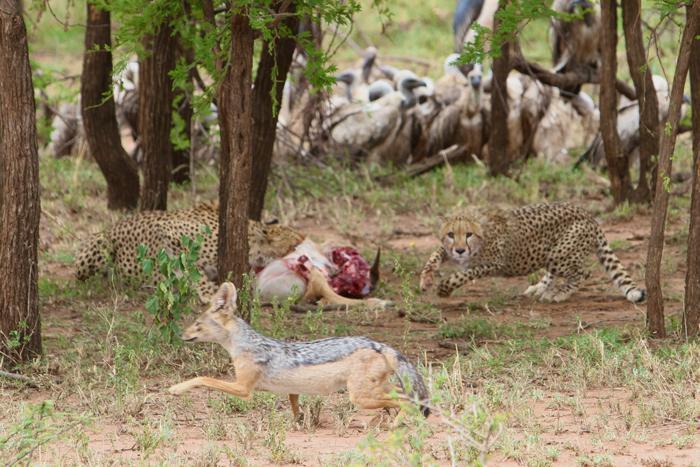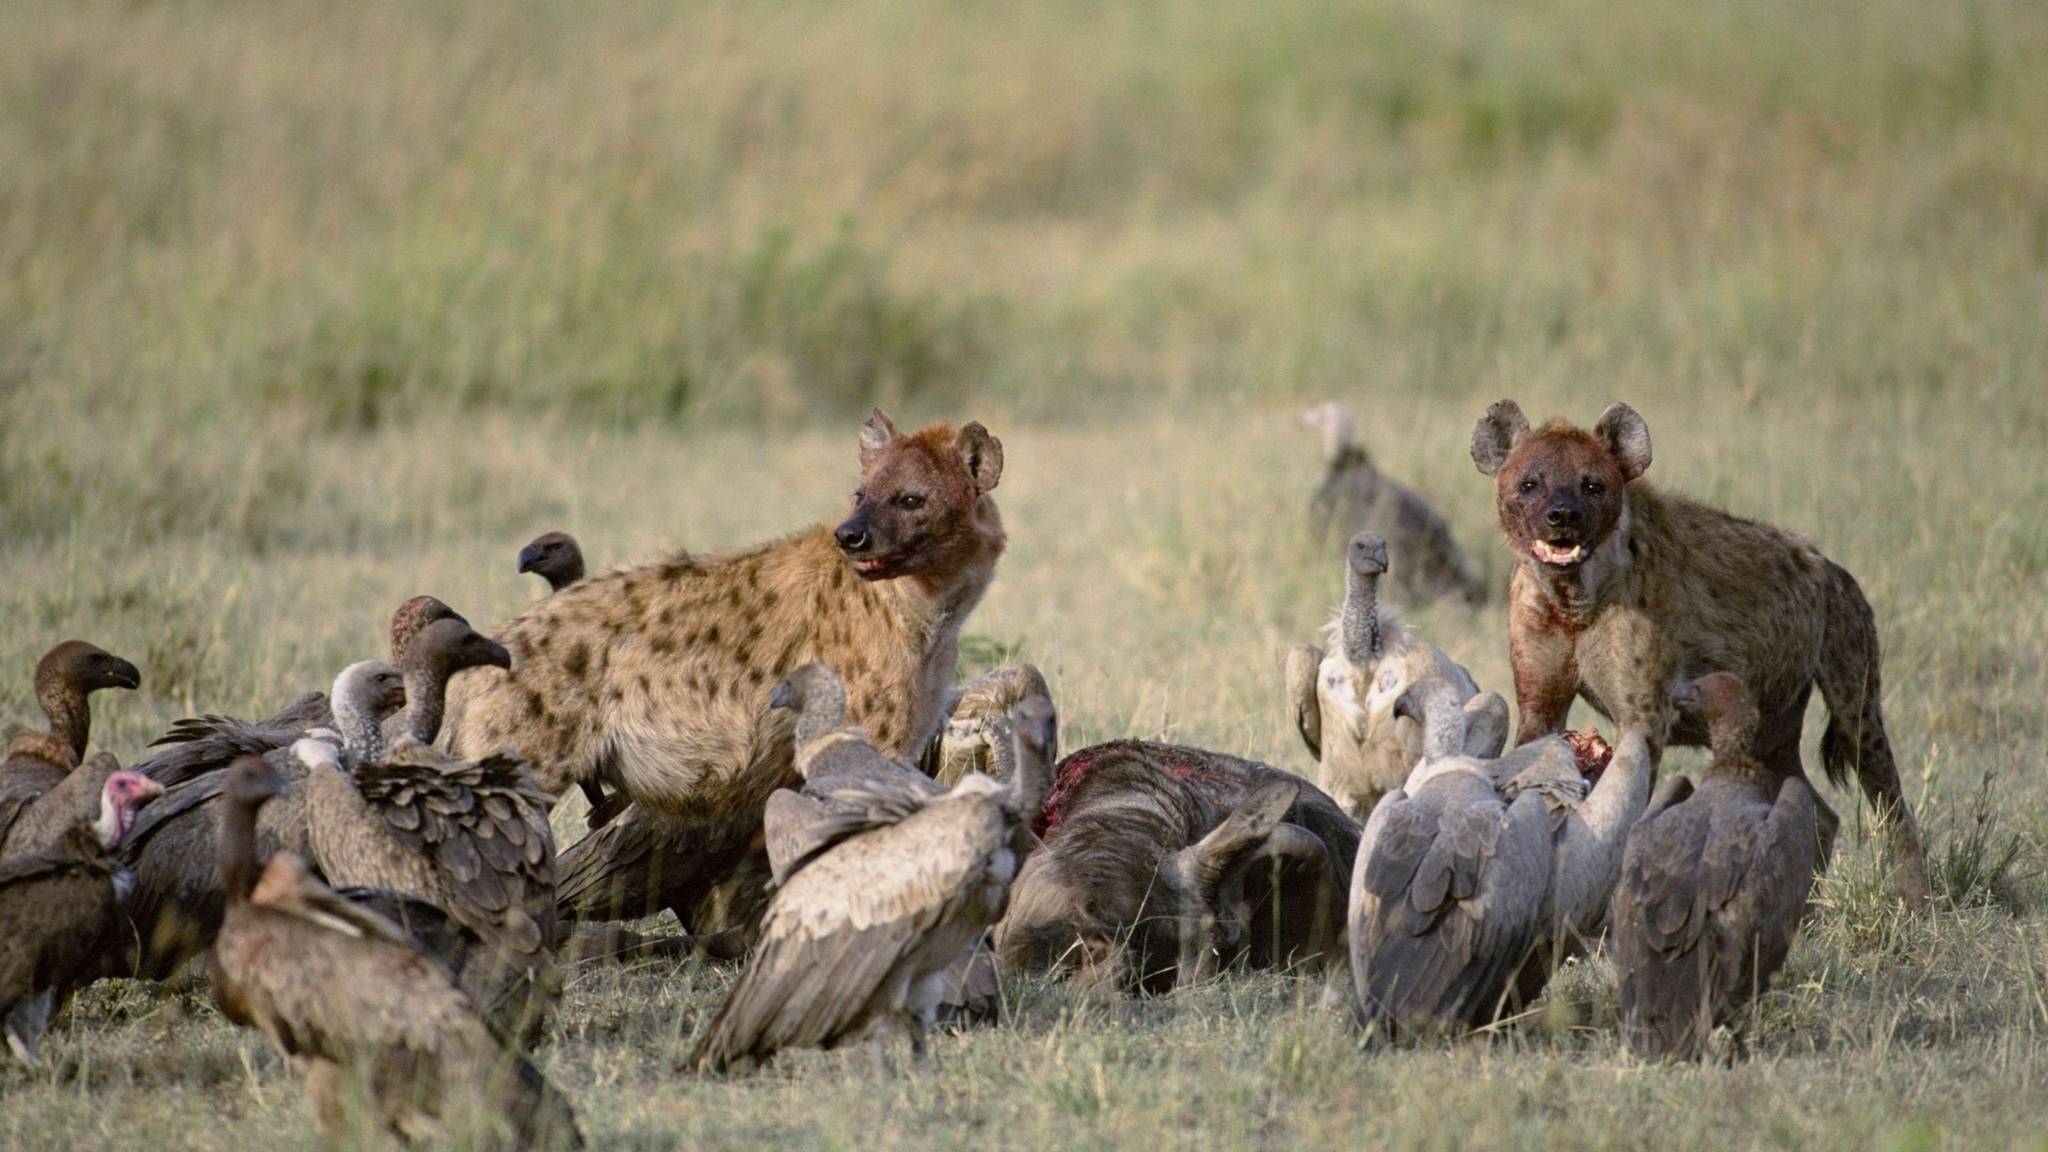The first image is the image on the left, the second image is the image on the right. Examine the images to the left and right. Is the description "At least one vulture is in the air." accurate? Answer yes or no. No. 